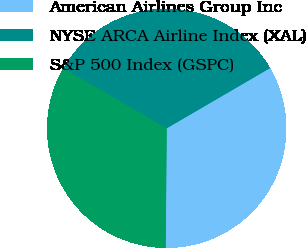Convert chart to OTSL. <chart><loc_0><loc_0><loc_500><loc_500><pie_chart><fcel>American Airlines Group Inc<fcel>NYSE ARCA Airline Index (XAL)<fcel>S&P 500 Index (GSPC)<nl><fcel>33.54%<fcel>33.21%<fcel>33.25%<nl></chart> 